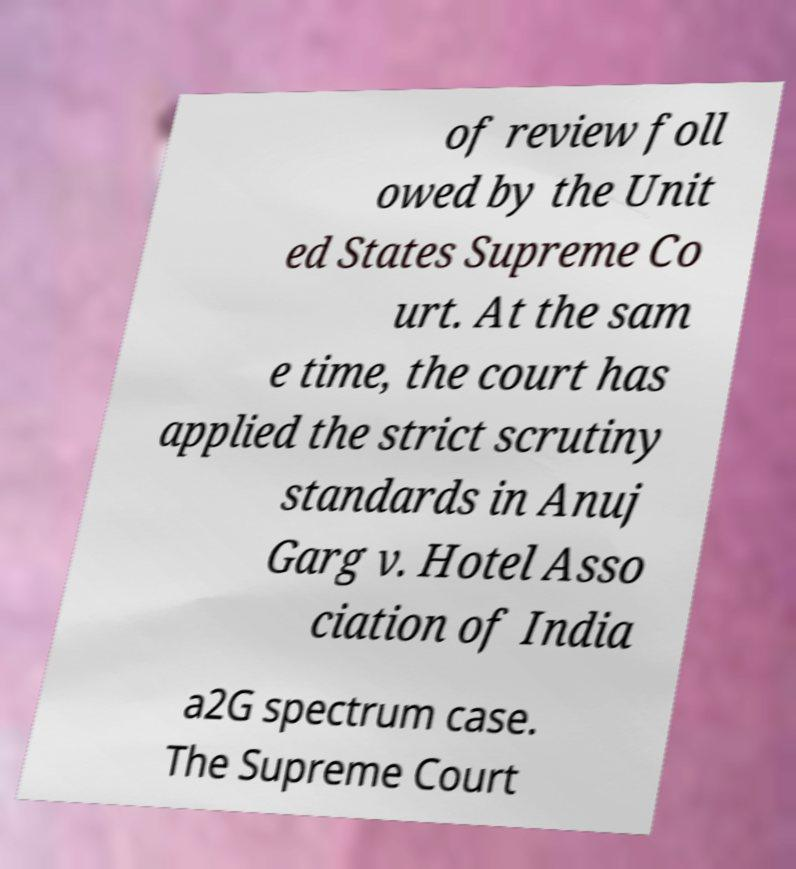Could you extract and type out the text from this image? of review foll owed by the Unit ed States Supreme Co urt. At the sam e time, the court has applied the strict scrutiny standards in Anuj Garg v. Hotel Asso ciation of India a2G spectrum case. The Supreme Court 